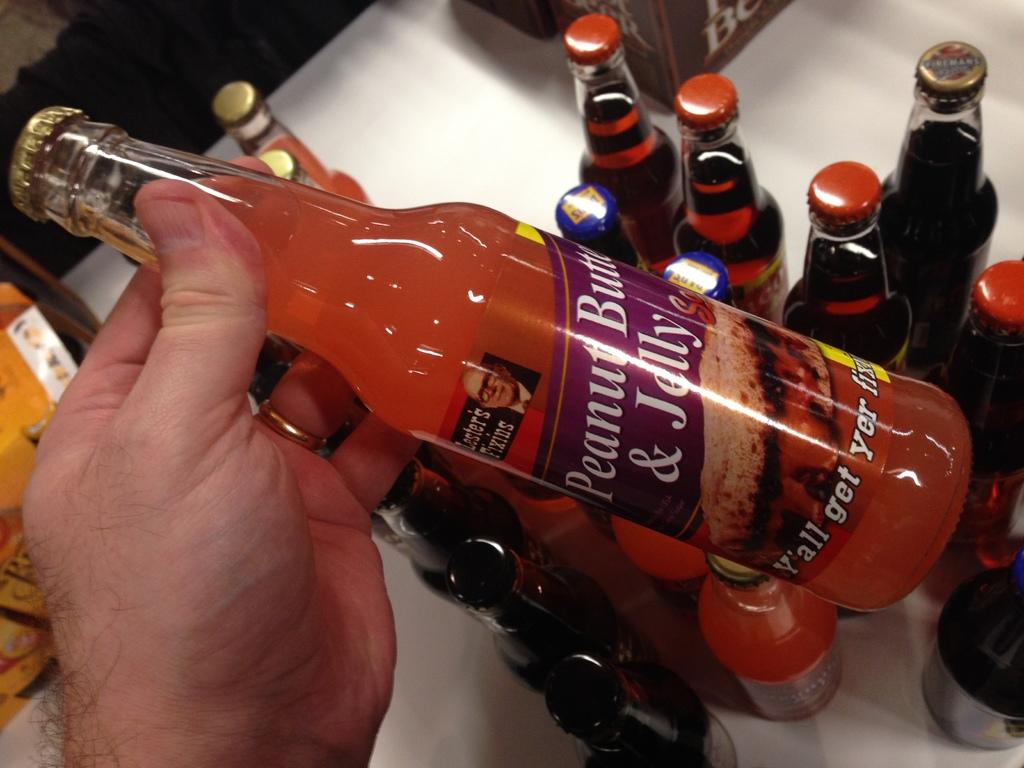<image>
Write a terse but informative summary of the picture. A person holding a bottle of Lester's Fixins Peanut Butter Jelly above other bottles on a table. 